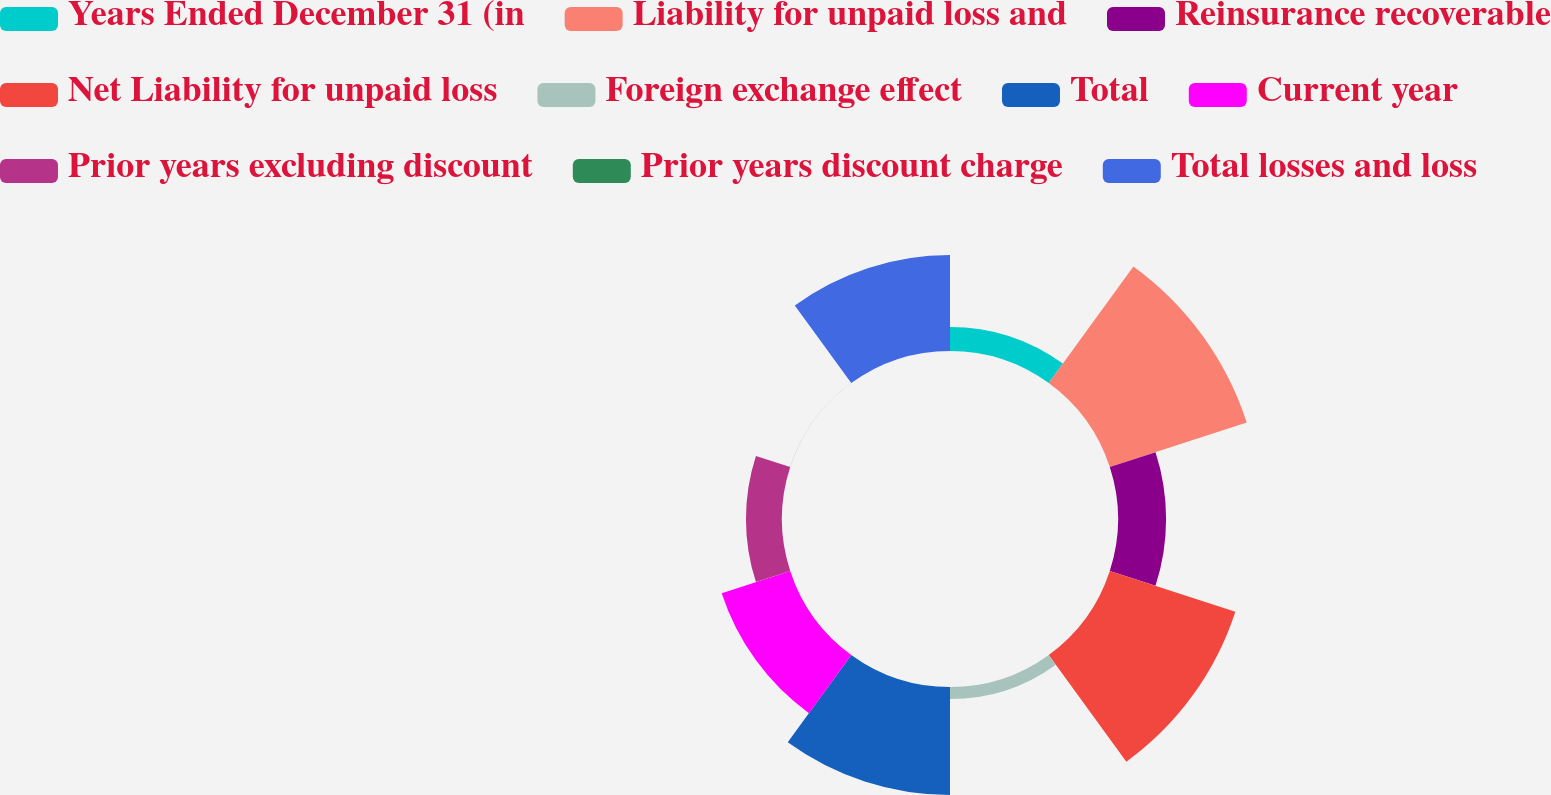<chart> <loc_0><loc_0><loc_500><loc_500><pie_chart><fcel>Years Ended December 31 (in<fcel>Liability for unpaid loss and<fcel>Reinsurance recoverable<fcel>Net Liability for unpaid loss<fcel>Foreign exchange effect<fcel>Total<fcel>Current year<fcel>Prior years excluding discount<fcel>Prior years discount charge<fcel>Total losses and loss<nl><fcel>3.58%<fcel>21.41%<fcel>7.15%<fcel>19.63%<fcel>1.8%<fcel>16.06%<fcel>10.71%<fcel>5.36%<fcel>0.02%<fcel>14.28%<nl></chart> 